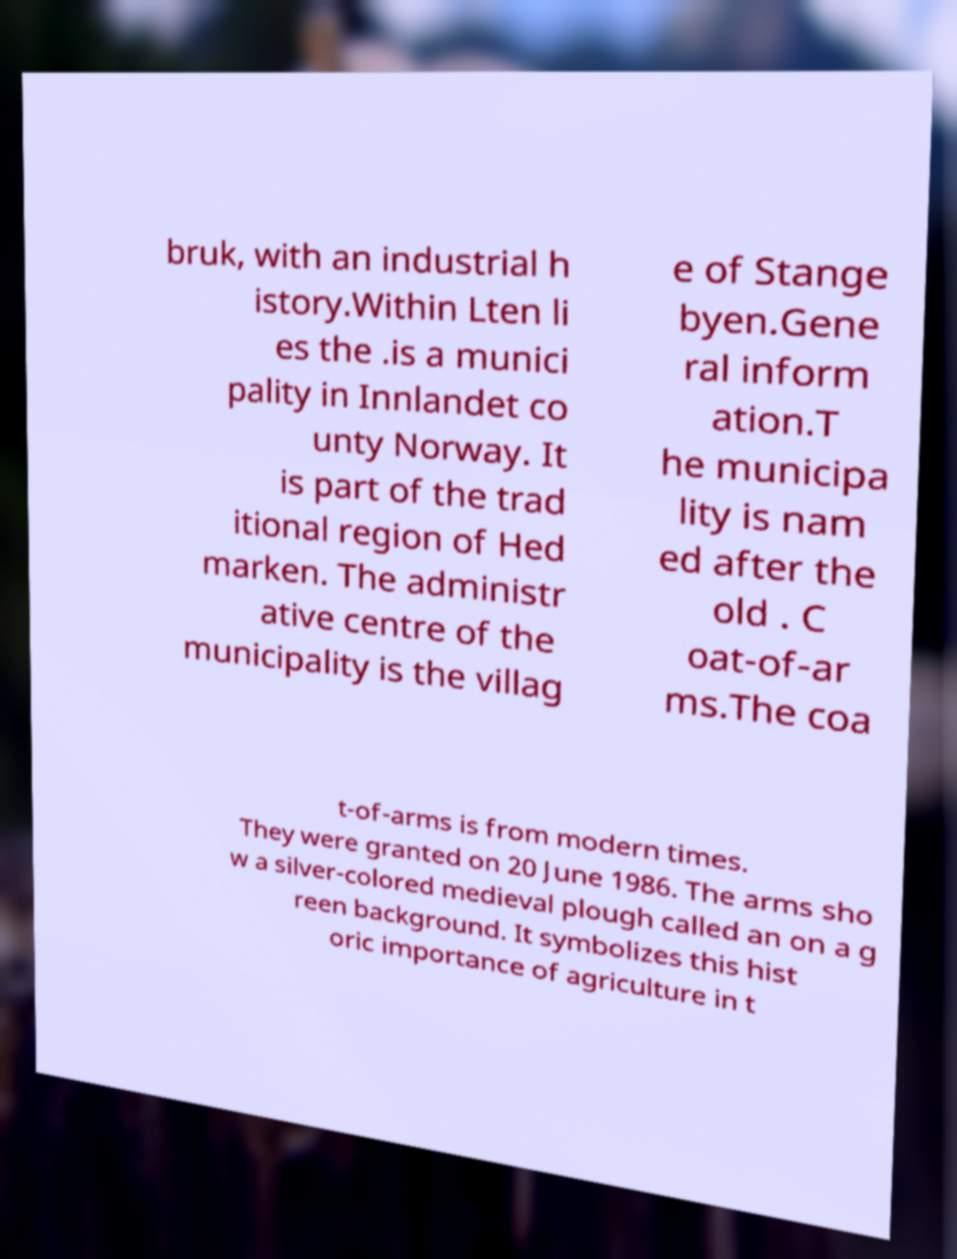I need the written content from this picture converted into text. Can you do that? bruk, with an industrial h istory.Within Lten li es the .is a munici pality in Innlandet co unty Norway. It is part of the trad itional region of Hed marken. The administr ative centre of the municipality is the villag e of Stange byen.Gene ral inform ation.T he municipa lity is nam ed after the old . C oat-of-ar ms.The coa t-of-arms is from modern times. They were granted on 20 June 1986. The arms sho w a silver-colored medieval plough called an on a g reen background. It symbolizes this hist oric importance of agriculture in t 